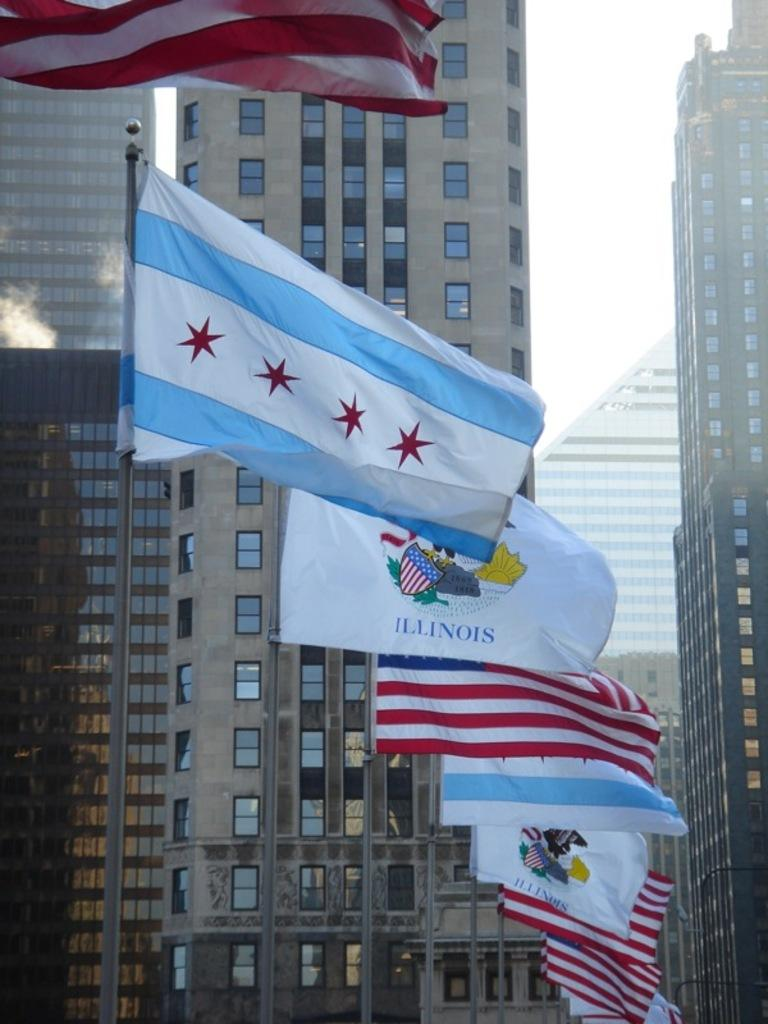What type of structures can be seen in the image? There are buildings in the image. Are there any other objects or features visible in the image? Yes, there are flags on poles in the image. What type of bait is being used to catch fish in the image? There is no mention of fish or bait in the image; it only features buildings and flags on poles. 